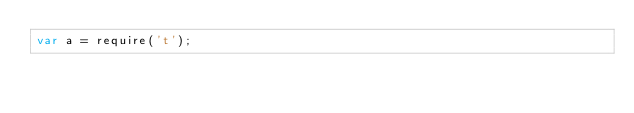Convert code to text. <code><loc_0><loc_0><loc_500><loc_500><_JavaScript_>var a = require('t');</code> 